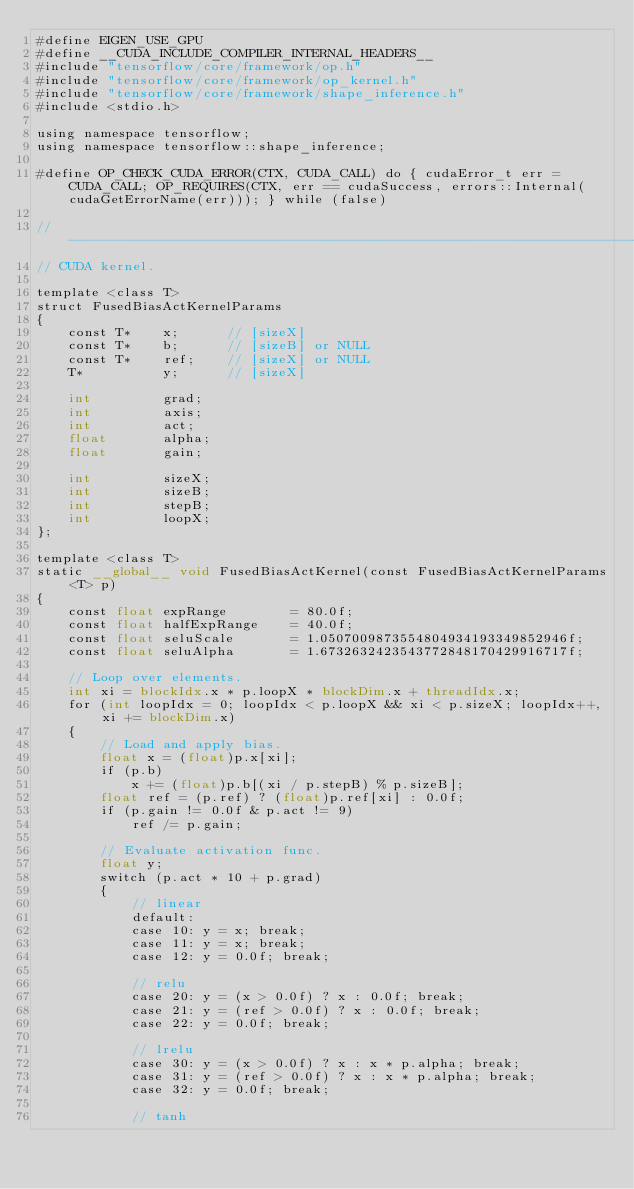Convert code to text. <code><loc_0><loc_0><loc_500><loc_500><_Cuda_>#define EIGEN_USE_GPU
#define __CUDA_INCLUDE_COMPILER_INTERNAL_HEADERS__
#include "tensorflow/core/framework/op.h"
#include "tensorflow/core/framework/op_kernel.h"
#include "tensorflow/core/framework/shape_inference.h"
#include <stdio.h>

using namespace tensorflow;
using namespace tensorflow::shape_inference;

#define OP_CHECK_CUDA_ERROR(CTX, CUDA_CALL) do { cudaError_t err = CUDA_CALL; OP_REQUIRES(CTX, err == cudaSuccess, errors::Internal(cudaGetErrorName(err))); } while (false)

//------------------------------------------------------------------------
// CUDA kernel.

template <class T>
struct FusedBiasActKernelParams
{
    const T*    x;      // [sizeX]
    const T*    b;      // [sizeB] or NULL
    const T*    ref;    // [sizeX] or NULL
    T*          y;      // [sizeX]

    int         grad;
    int         axis;
    int         act;
    float       alpha;
    float       gain;

    int         sizeX;
    int         sizeB;
    int         stepB;
    int         loopX;
};

template <class T>
static __global__ void FusedBiasActKernel(const FusedBiasActKernelParams<T> p)
{
    const float expRange        = 80.0f;
    const float halfExpRange    = 40.0f;
    const float seluScale       = 1.0507009873554804934193349852946f;
    const float seluAlpha       = 1.6732632423543772848170429916717f;

    // Loop over elements.
    int xi = blockIdx.x * p.loopX * blockDim.x + threadIdx.x;
    for (int loopIdx = 0; loopIdx < p.loopX && xi < p.sizeX; loopIdx++, xi += blockDim.x)
    {
        // Load and apply bias.
        float x = (float)p.x[xi];
        if (p.b)
            x += (float)p.b[(xi / p.stepB) % p.sizeB];
        float ref = (p.ref) ? (float)p.ref[xi] : 0.0f;
        if (p.gain != 0.0f & p.act != 9)
            ref /= p.gain;

        // Evaluate activation func.
        float y;
        switch (p.act * 10 + p.grad)
        {
            // linear
            default:
            case 10: y = x; break;
            case 11: y = x; break;
            case 12: y = 0.0f; break;

            // relu
            case 20: y = (x > 0.0f) ? x : 0.0f; break;
            case 21: y = (ref > 0.0f) ? x : 0.0f; break;
            case 22: y = 0.0f; break;

            // lrelu
            case 30: y = (x > 0.0f) ? x : x * p.alpha; break;
            case 31: y = (ref > 0.0f) ? x : x * p.alpha; break;
            case 32: y = 0.0f; break;

            // tanh</code> 